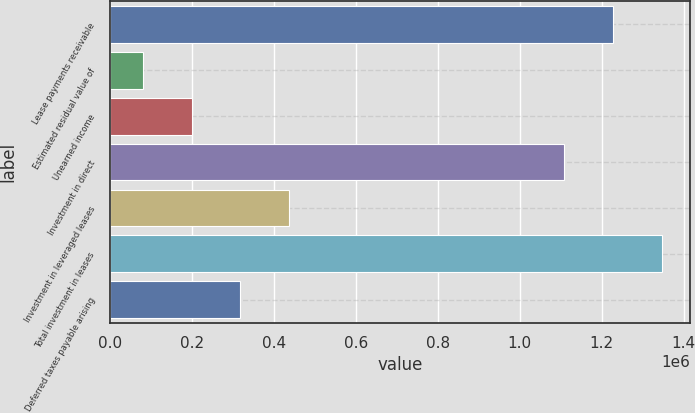Convert chart. <chart><loc_0><loc_0><loc_500><loc_500><bar_chart><fcel>Lease payments receivable<fcel>Estimated residual value of<fcel>Unearned income<fcel>Investment in direct<fcel>Investment in leveraged leases<fcel>Total investment in leases<fcel>Deferred taxes payable arising<nl><fcel>1.22811e+06<fcel>79449<fcel>198826<fcel>1.10873e+06<fcel>437579<fcel>1.34748e+06<fcel>318202<nl></chart> 